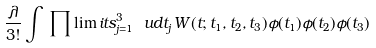<formula> <loc_0><loc_0><loc_500><loc_500>\frac { \lambda } { 3 ! } \int \, \prod \lim i t s _ { j = 1 } ^ { 3 } \ u d t _ { j } \, W ( t ; t _ { 1 } , t _ { 2 } , t _ { 3 } ) \phi ( t _ { 1 } ) \phi ( t _ { 2 } ) \phi ( t _ { 3 } )</formula> 